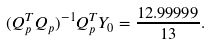<formula> <loc_0><loc_0><loc_500><loc_500>( Q _ { p } ^ { T } Q _ { p } ) ^ { - 1 } Q _ { p } ^ { T } Y _ { 0 } = \frac { 1 2 . 9 9 9 9 9 } { 1 3 } .</formula> 